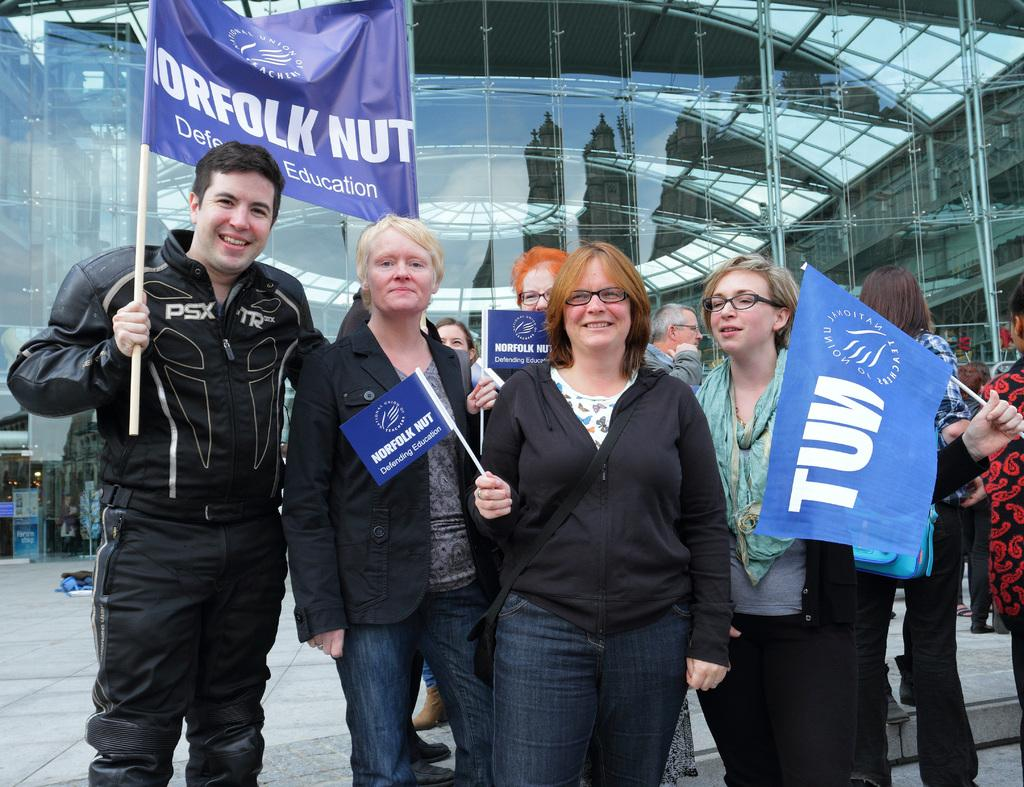What is the main subject of the image? The main subject of the image is a crowd. Where are the people in the crowd located? The people in the crowd are standing on the floor. What are the people in the crowd holding? The people in the crowd are holding flags. What can be seen in the background of the image? There is a building with mirrors in the background of the image. How many pizzas are being served to the crowd in the image? There is no mention of pizzas in the image; the people in the crowd are holding flags. What type of lipstick is the person in the front row wearing in the image? There is no information about lipstick or any individual person's appearance in the image; it focuses on the crowd as a whole. 